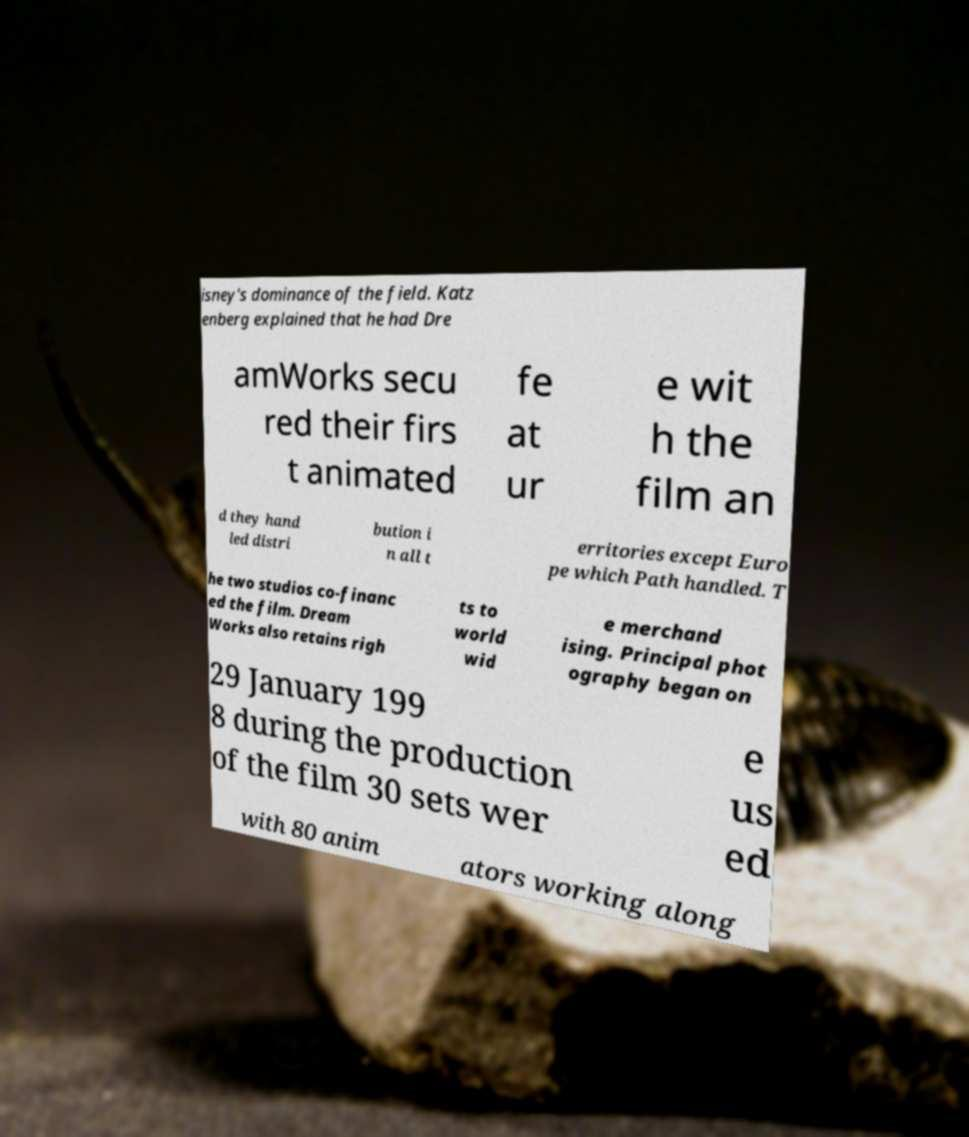Please read and relay the text visible in this image. What does it say? isney's dominance of the field. Katz enberg explained that he had Dre amWorks secu red their firs t animated fe at ur e wit h the film an d they hand led distri bution i n all t erritories except Euro pe which Path handled. T he two studios co-financ ed the film. Dream Works also retains righ ts to world wid e merchand ising. Principal phot ography began on 29 January 199 8 during the production of the film 30 sets wer e us ed with 80 anim ators working along 